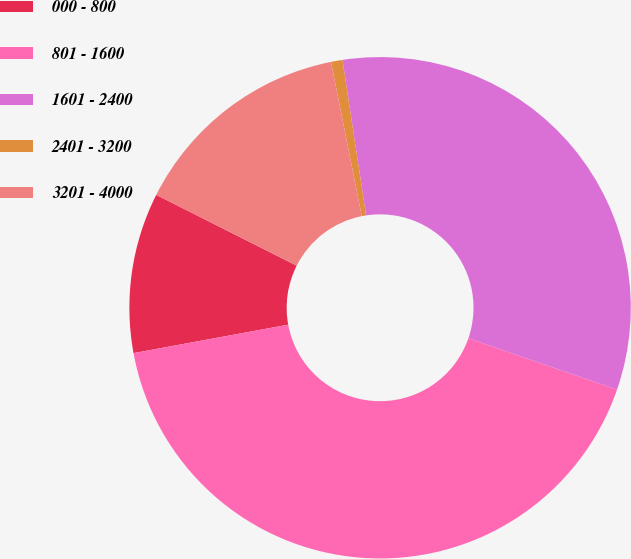Convert chart. <chart><loc_0><loc_0><loc_500><loc_500><pie_chart><fcel>000 - 800<fcel>801 - 1600<fcel>1601 - 2400<fcel>2401 - 3200<fcel>3201 - 4000<nl><fcel>10.33%<fcel>41.81%<fcel>32.69%<fcel>0.74%<fcel>14.43%<nl></chart> 